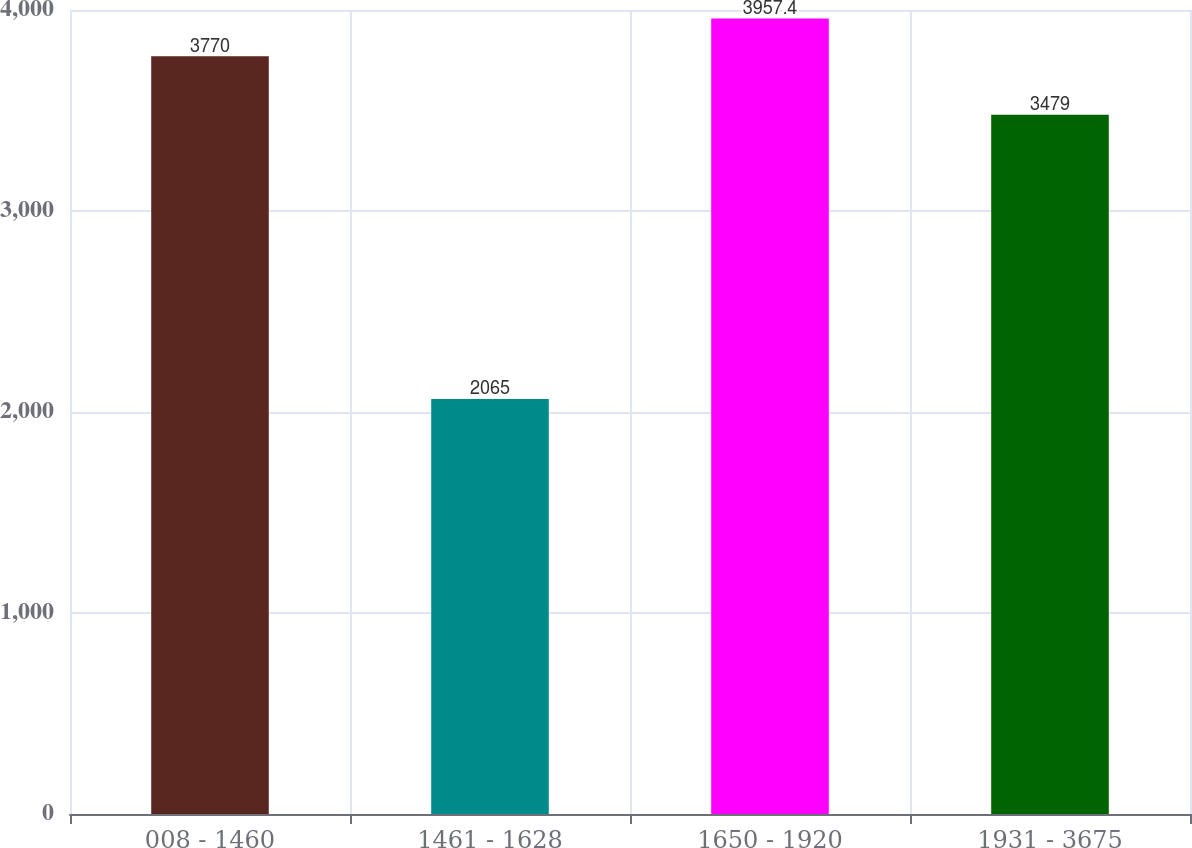Convert chart. <chart><loc_0><loc_0><loc_500><loc_500><bar_chart><fcel>008 - 1460<fcel>1461 - 1628<fcel>1650 - 1920<fcel>1931 - 3675<nl><fcel>3770<fcel>2065<fcel>3957.4<fcel>3479<nl></chart> 